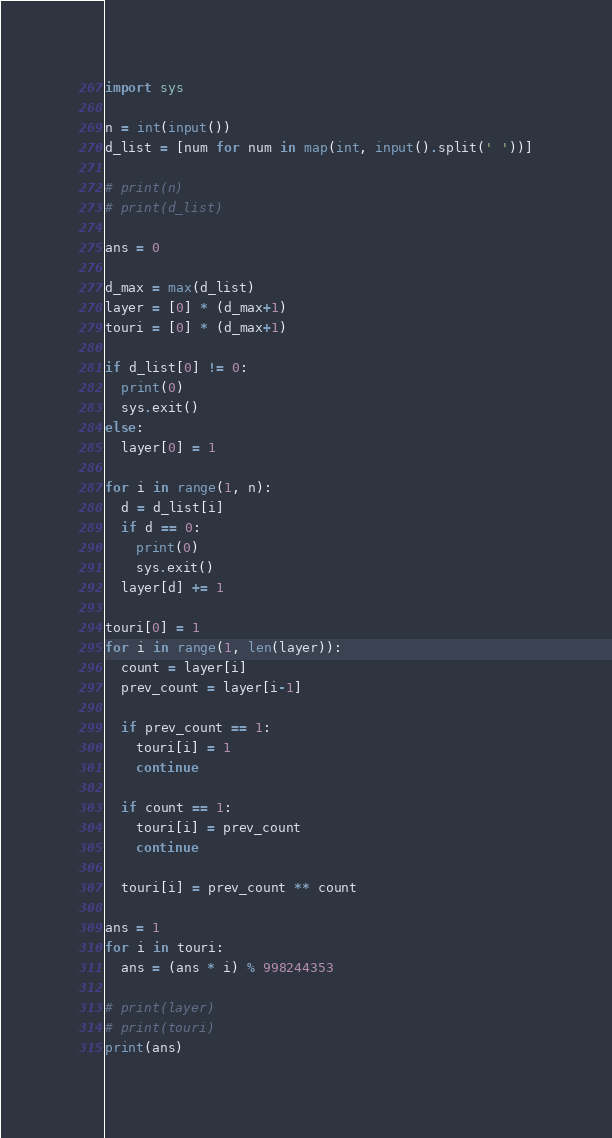Convert code to text. <code><loc_0><loc_0><loc_500><loc_500><_Python_>import sys

n = int(input())
d_list = [num for num in map(int, input().split(' '))]

# print(n)
# print(d_list)

ans = 0

d_max = max(d_list)
layer = [0] * (d_max+1)
touri = [0] * (d_max+1)

if d_list[0] != 0:
  print(0)
  sys.exit()
else:
  layer[0] = 1

for i in range(1, n):
  d = d_list[i]
  if d == 0:
    print(0)
    sys.exit()
  layer[d] += 1

touri[0] = 1
for i in range(1, len(layer)):
  count = layer[i]
  prev_count = layer[i-1]
  
  if prev_count == 1:
    touri[i] = 1
    continue
  
  if count == 1:
    touri[i] = prev_count
    continue
  
  touri[i] = prev_count ** count
    
ans = 1
for i in touri:
  ans = (ans * i) % 998244353
  
# print(layer)
# print(touri)
print(ans)
</code> 